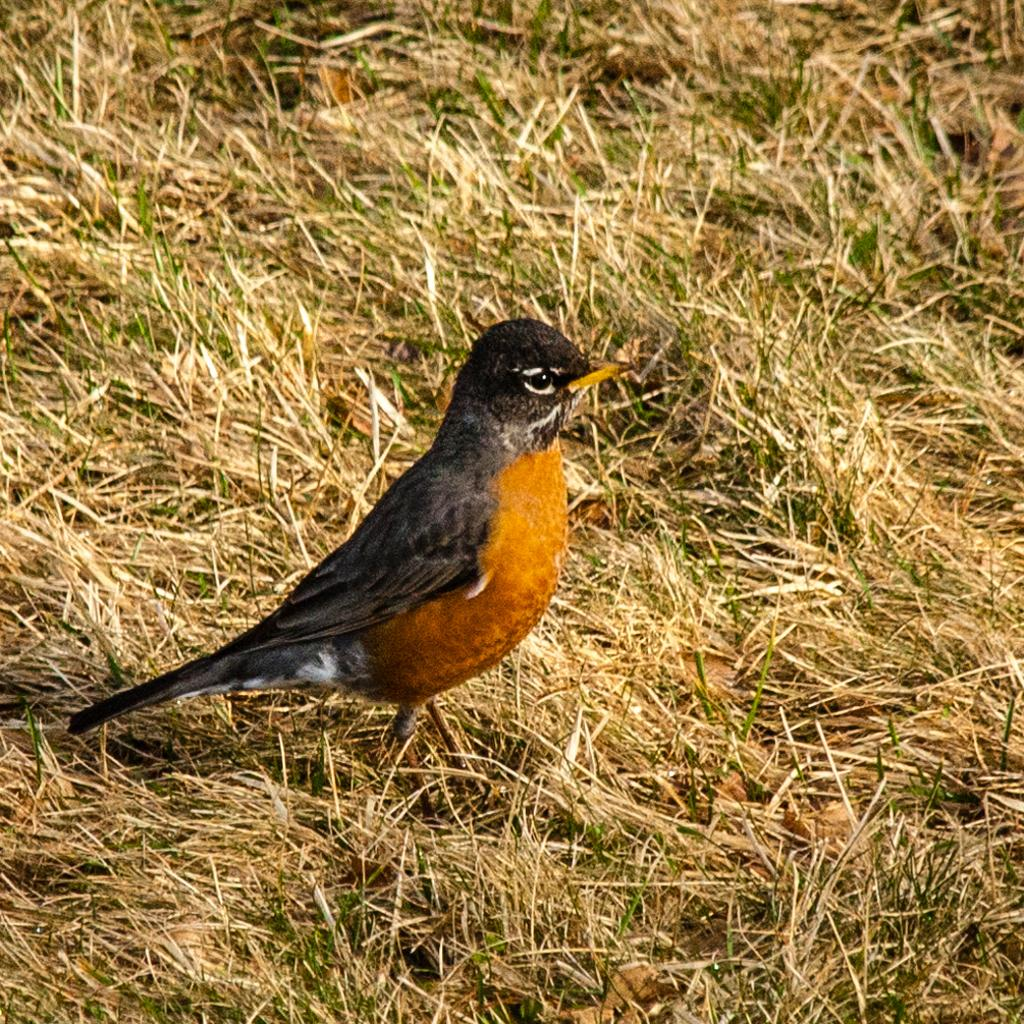What type of animal can be seen in the image? There is a bird in the image. What is the bird standing on? The bird is standing on dried grass. Can you describe the bird's coloring? The bird has black and brown coloring. What time of day is the bird enjoying its vacation in the image? There is no indication of a vacation or a specific time of day in the image; it simply shows a bird standing on dried grass. 